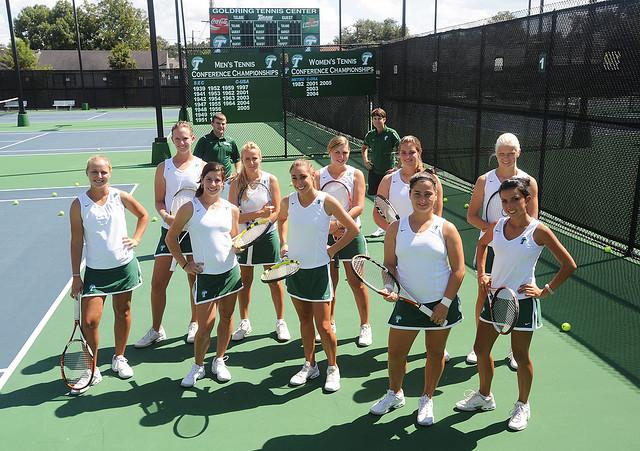Is this a men's tennis team?
Be succinct. No. How many women?
Keep it brief. 10. What are the women holding?
Keep it brief. Rackets. 